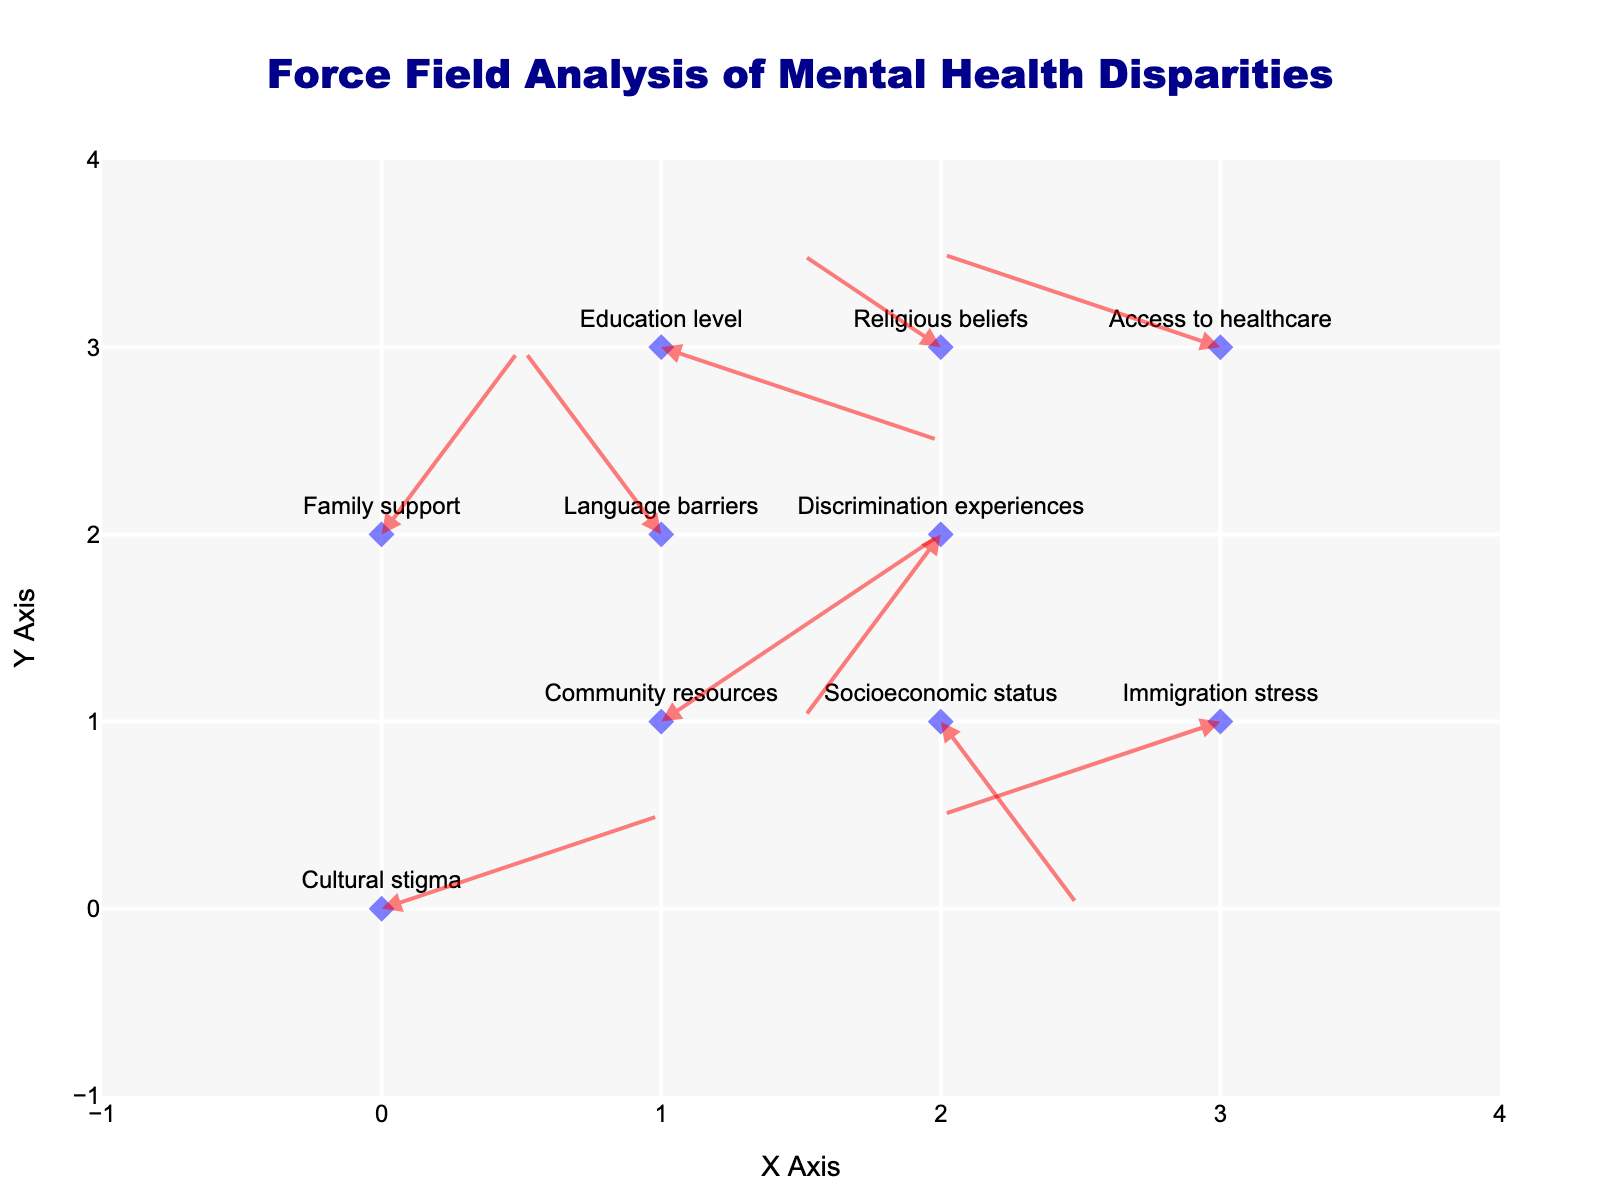What is the title of the figure? The title of the figure is located at the top and reads "Force Field Analysis of Mental Health Disparities".
Answer: Force Field Analysis of Mental Health Disparities How many factors are being analyzed in the figure? Count all the labels (factors) listed in the figure. There are 10 factors in total.
Answer: 10 Which factor shows the largest positive influence in both X and Y directions? Find the data point with the biggest positive `u` and `v` values. "Community resources" has `u` = 2 and `v` = 2, the largest positive influence in both X and Y directions.
Answer: Community resources Compare the influence of 'Cultural stigma' and 'Language barriers' along the X-axis. Which one has a greater impact? 'Cultural stigma' has `u` = 2 along the X-axis, and 'Language barriers' has `u` = -1. 2 is greater than -1, so 'Cultural stigma' has a greater impact.
Answer: Cultural stigma What is the sum of the influences of 'Socioeconomic status' along both the X and Y directions? The `u` value for 'Socioeconomic status' is 1 and the `v` value is -2. Adding these values together, 1 + (-2) = -1.
Answer: -1 Which factor shows a negative influence in both X and Y directions and what are its values? Find the data point with both negative `u` and `v`. 'Discrimination experiences' has `u` = -1 and `v` = -2.
Answer: Discrimination experiences; u = -1, v = -2 What is the combined influence of 'Access to healthcare' along both the X and Y directions? The `u` value for 'Access to healthcare' is -2 and the `v` value is 1. Adding these values together, -2 + 1 = -1.
Answer: -1 Which factor has its arrow pointing to the bottom right? An arrow pointing to the bottom right direction means `u` > 0 and `v` < 0. 'Education level' has `u` = 2 and `v` = -1, pointing to the bottom right.
Answer: Education level How does 'Religious beliefs' compare to 'Immigration stress' in terms of influence along the Y-axis? 'Religious beliefs' has a `v` value of 1 and 'Immigration stress' has a `v` value of -1. Since 1 is greater than -1, 'Religious beliefs' has a greater influence along the Y-axis.
Answer: Religious beliefs 